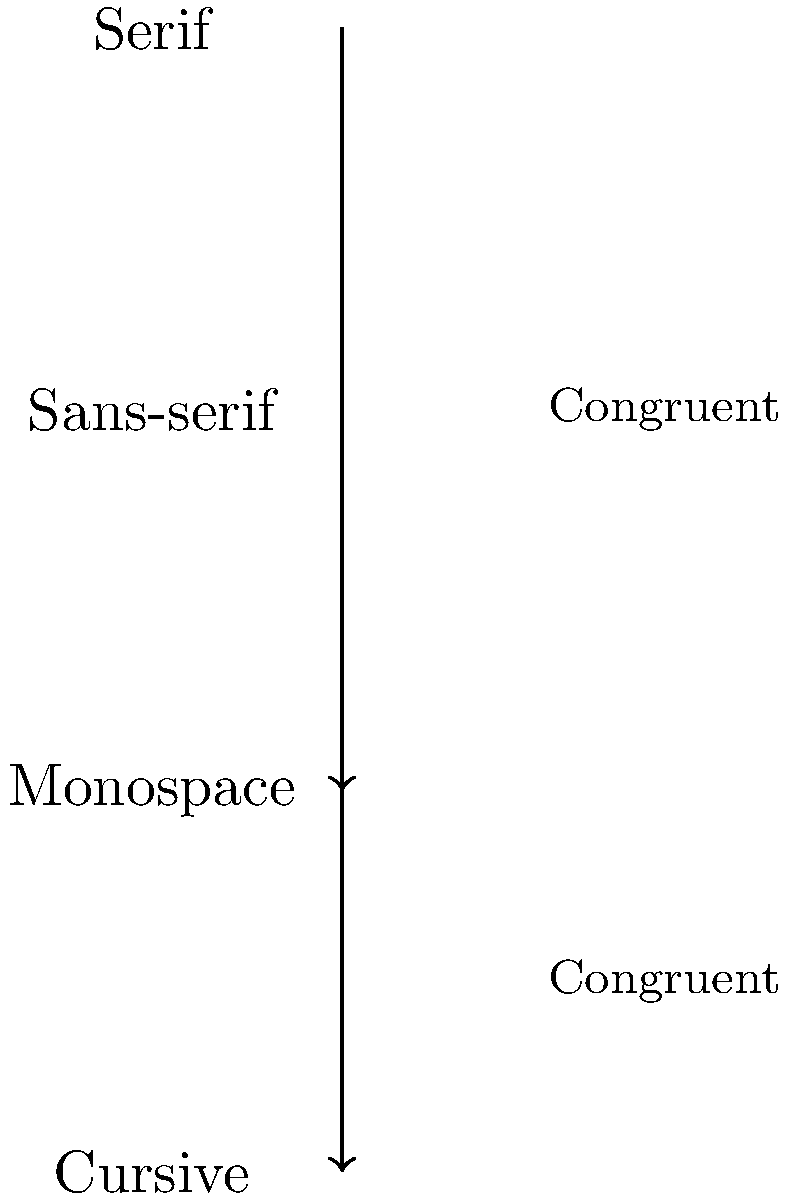In the context of typography in classic literature, which pair of font styles demonstrates congruence according to the diagram, and how might this impact the reading experience for a discerning literary scholar? To answer this question, let's analyze the diagram step-by-step:

1. The diagram shows four font styles: Serif, Sans-serif, Monospace, and Cursive.

2. There are two arrows indicating congruence between different pairs of font styles:
   a) One arrow connects Serif and Monospace
   b) Another arrow connects Sans-serif and Cursive

3. In typography, congruence refers to the visual harmony or compatibility between different font styles.

4. The pair of font styles demonstrating congruence, according to the diagram, are:
   a) Serif and Monospace
   b) Sans-serif and Cursive

5. Impact on reading experience for a literary scholar:
   a) Serif fonts are often used in classic literature for their readability in long texts.
   b) Monospace fonts, while less common in literature, can provide a unique aesthetic and may be used for specific purposes, such as representing typewritten text.
   c) The congruence between Serif and Monospace suggests that these styles could be used interchangeably or in combination without disrupting the reading flow.

6. From a literary scholar's perspective, this congruence could allow for:
   a) Seamless integration of quoted typewritten material within a serif-based text.
   b) Creative typographical choices that maintain readability while adding visual interest.
   c) Exploration of how font choices impact the interpretation and mood of a text.

The irony lies in the unexpected pairing of these seemingly disparate font styles, which could provide a subtle visual commentary on the text itself – a detail that would likely be appreciated by a scholar with a keen eye for nuance and metafictional elements in literature.
Answer: Serif and Monospace; enhances integration of typewritten quotes and allows for nuanced typographical commentary. 